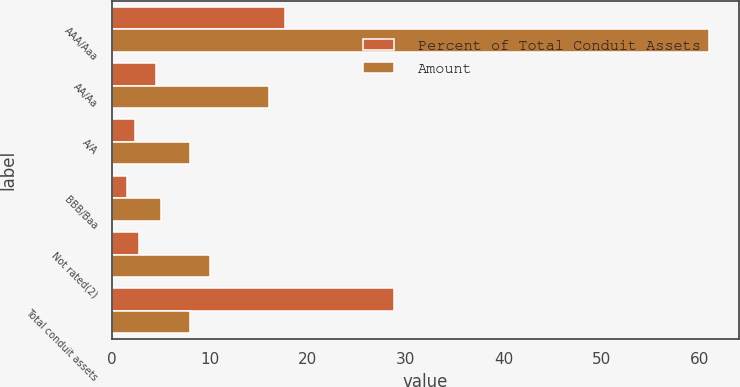<chart> <loc_0><loc_0><loc_500><loc_500><stacked_bar_chart><ecel><fcel>AAA/Aaa<fcel>AA/Aa<fcel>A/A<fcel>BBB/Baa<fcel>Not rated(2)<fcel>Total conduit assets<nl><fcel>Percent of Total Conduit Assets<fcel>17.7<fcel>4.5<fcel>2.3<fcel>1.5<fcel>2.8<fcel>28.8<nl><fcel>Amount<fcel>61<fcel>16<fcel>8<fcel>5<fcel>10<fcel>8<nl></chart> 